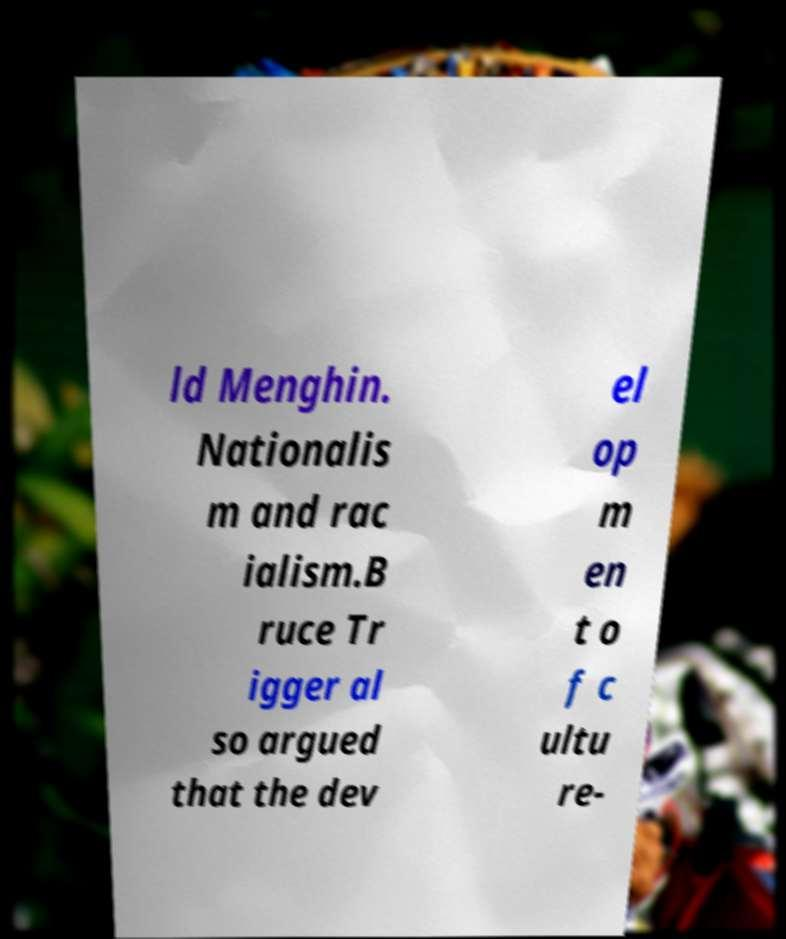Can you accurately transcribe the text from the provided image for me? ld Menghin. Nationalis m and rac ialism.B ruce Tr igger al so argued that the dev el op m en t o f c ultu re- 